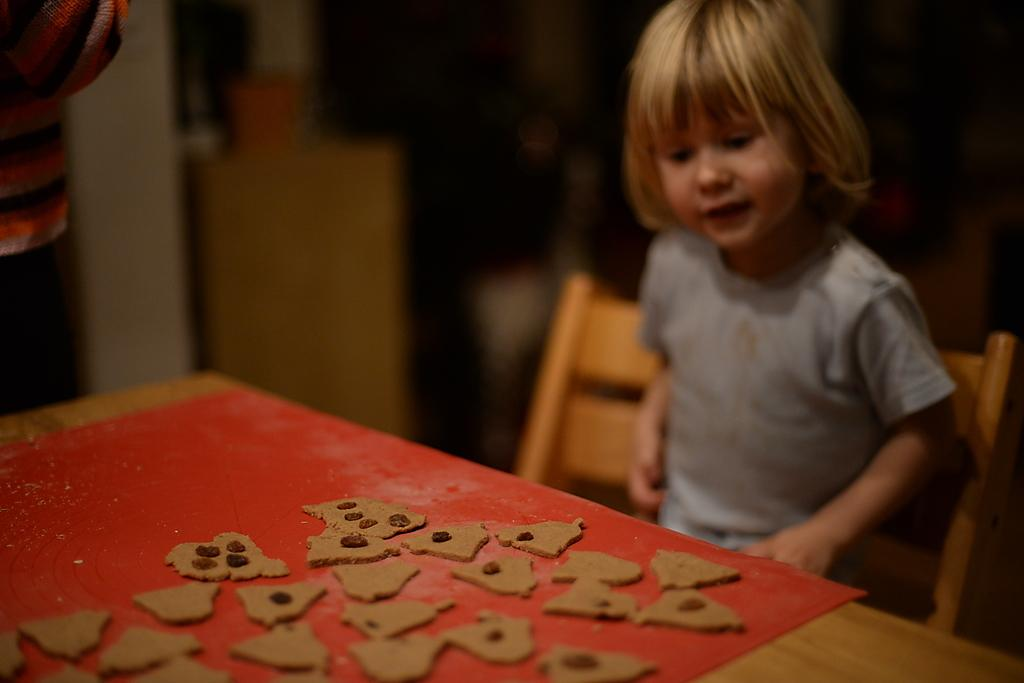What is the girl in the image doing? The girl is sitting on a chair in the image. What can be seen on the table in the image? There are many biscuits on a table in the image. Can you describe the other person in the image? There is a person standing in the image. What type of cave can be seen in the background of the image? There is no cave present in the image; it features a girl sitting on a chair and a person standing near a table with biscuits. 